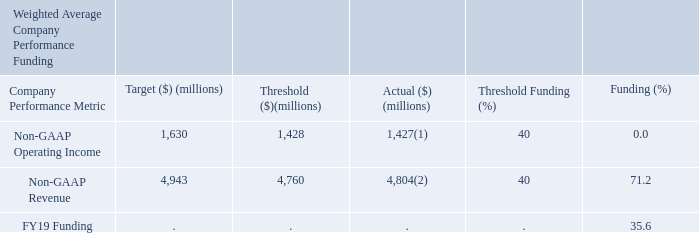FY19 EAIP Payout Results:
(1) Calculated in FY19 plan exchange rates and excludes stock-based compensation expense, charges related to the amortization of intangible assets, restructuring, separation, transition and other related expenses, contract liabilities fair value adjustment, acquisition-related costs and certain litigation settlement gains.
(2) Calculated in FY19 plan exchange rates and excludes contract liabilities fair value adjustment.
What is the target Non-GAAP Revenue?
Answer scale should be: million. 4,943. What is the FY19 Funding?
Answer scale should be: percent. 35.6. What are the units used for money in this table? Millions. What is the difference between Actual and Target for Non-GAAP Operating Income?
Answer scale should be: million. 1,630-1,427
Answer: 203. What is the difference between Actual and Target for Non-GAAP Revenue?
Answer scale should be: million. 4,943-4,804
Answer: 139. For Non-GAAP Revenue, how much is the target more than the actual in terms of percentages? 
Answer scale should be: percent. (4,943-4,804)/4,804
Answer: 2.89. 